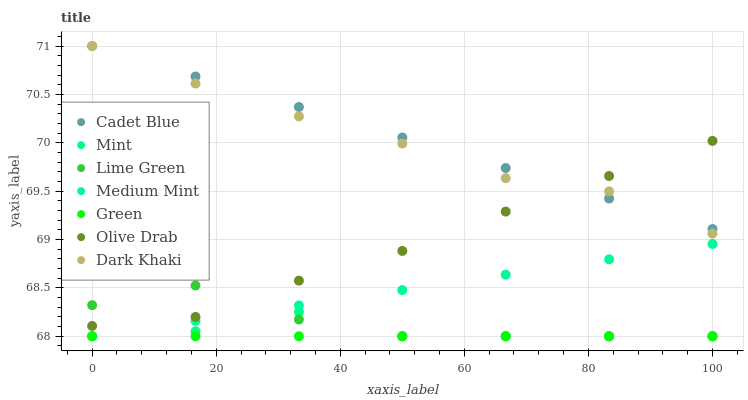Does Green have the minimum area under the curve?
Answer yes or no. Yes. Does Cadet Blue have the maximum area under the curve?
Answer yes or no. Yes. Does Mint have the minimum area under the curve?
Answer yes or no. No. Does Mint have the maximum area under the curve?
Answer yes or no. No. Is Green the smoothest?
Answer yes or no. Yes. Is Lime Green the roughest?
Answer yes or no. Yes. Is Cadet Blue the smoothest?
Answer yes or no. No. Is Cadet Blue the roughest?
Answer yes or no. No. Does Medium Mint have the lowest value?
Answer yes or no. Yes. Does Cadet Blue have the lowest value?
Answer yes or no. No. Does Dark Khaki have the highest value?
Answer yes or no. Yes. Does Mint have the highest value?
Answer yes or no. No. Is Green less than Olive Drab?
Answer yes or no. Yes. Is Dark Khaki greater than Lime Green?
Answer yes or no. Yes. Does Dark Khaki intersect Cadet Blue?
Answer yes or no. Yes. Is Dark Khaki less than Cadet Blue?
Answer yes or no. No. Is Dark Khaki greater than Cadet Blue?
Answer yes or no. No. Does Green intersect Olive Drab?
Answer yes or no. No. 